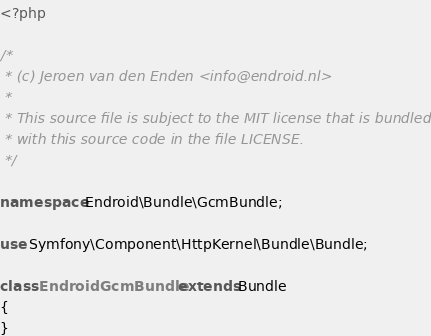<code> <loc_0><loc_0><loc_500><loc_500><_PHP_><?php

/*
 * (c) Jeroen van den Enden <info@endroid.nl>
 *
 * This source file is subject to the MIT license that is bundled
 * with this source code in the file LICENSE.
 */

namespace Endroid\Bundle\GcmBundle;

use Symfony\Component\HttpKernel\Bundle\Bundle;

class EndroidGcmBundle extends Bundle
{
}
</code> 